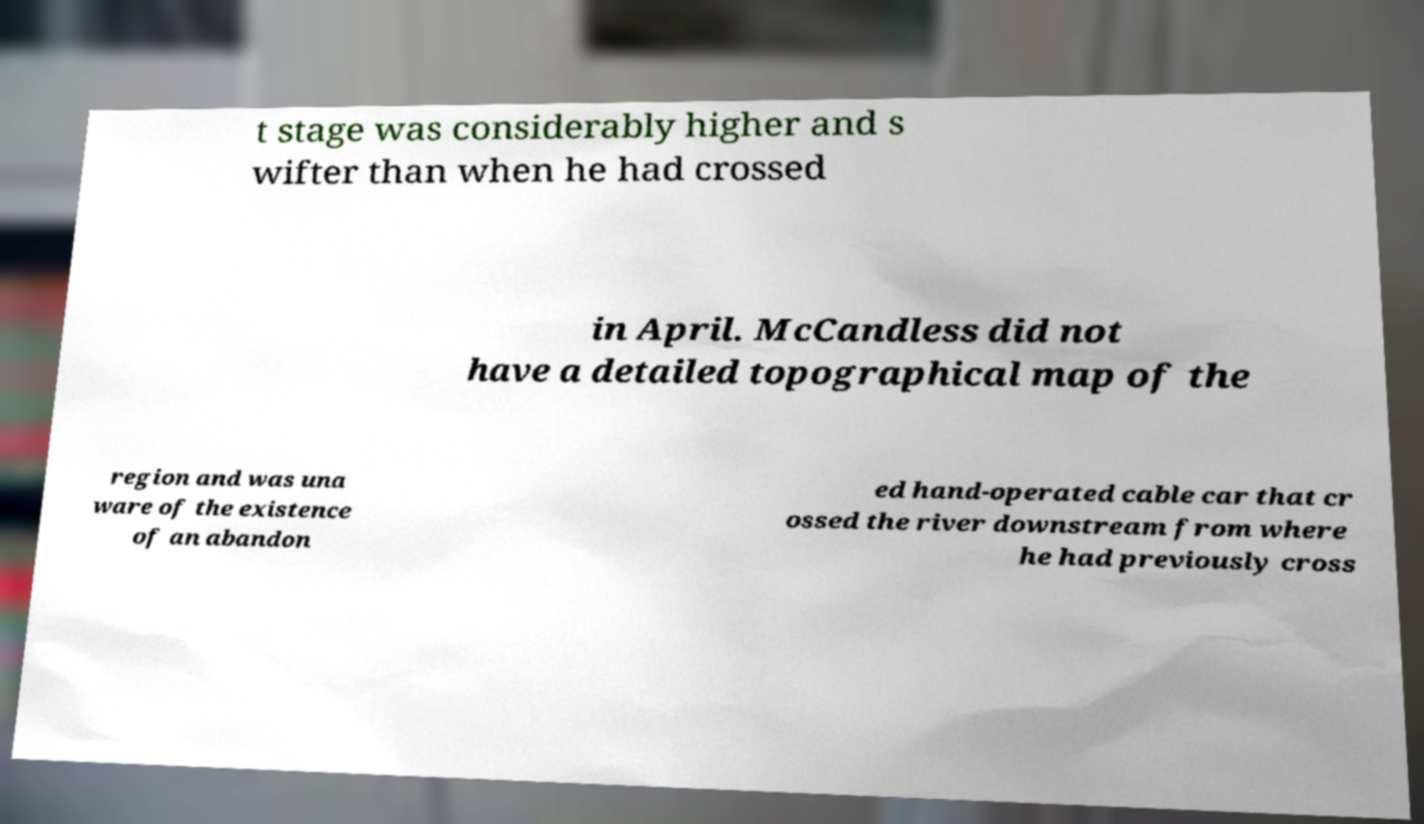Please identify and transcribe the text found in this image. t stage was considerably higher and s wifter than when he had crossed in April. McCandless did not have a detailed topographical map of the region and was una ware of the existence of an abandon ed hand-operated cable car that cr ossed the river downstream from where he had previously cross 